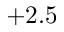Convert formula to latex. <formula><loc_0><loc_0><loc_500><loc_500>+ 2 . 5</formula> 